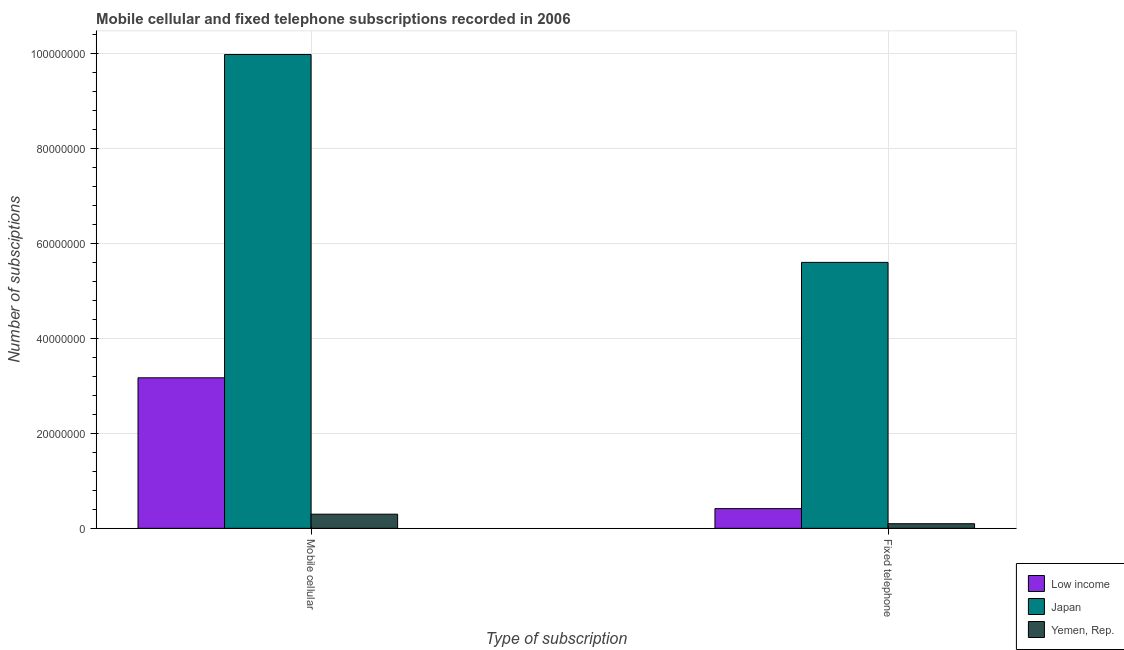What is the label of the 1st group of bars from the left?
Your answer should be very brief. Mobile cellular. What is the number of fixed telephone subscriptions in Japan?
Provide a short and direct response. 5.60e+07. Across all countries, what is the maximum number of mobile cellular subscriptions?
Your response must be concise. 9.98e+07. Across all countries, what is the minimum number of mobile cellular subscriptions?
Provide a succinct answer. 2.98e+06. In which country was the number of mobile cellular subscriptions maximum?
Offer a very short reply. Japan. In which country was the number of mobile cellular subscriptions minimum?
Give a very brief answer. Yemen, Rep. What is the total number of mobile cellular subscriptions in the graph?
Provide a short and direct response. 1.35e+08. What is the difference between the number of mobile cellular subscriptions in Low income and that in Yemen, Rep.?
Keep it short and to the point. 2.87e+07. What is the difference between the number of fixed telephone subscriptions in Yemen, Rep. and the number of mobile cellular subscriptions in Low income?
Make the answer very short. -3.07e+07. What is the average number of mobile cellular subscriptions per country?
Offer a terse response. 4.48e+07. What is the difference between the number of fixed telephone subscriptions and number of mobile cellular subscriptions in Japan?
Your answer should be compact. -4.38e+07. In how many countries, is the number of fixed telephone subscriptions greater than 40000000 ?
Provide a succinct answer. 1. What is the ratio of the number of fixed telephone subscriptions in Japan to that in Yemen, Rep.?
Ensure brevity in your answer.  57.86. What does the 2nd bar from the left in Fixed telephone represents?
Give a very brief answer. Japan. What does the 1st bar from the right in Mobile cellular represents?
Provide a succinct answer. Yemen, Rep. How many bars are there?
Make the answer very short. 6. Does the graph contain any zero values?
Offer a very short reply. No. Where does the legend appear in the graph?
Keep it short and to the point. Bottom right. What is the title of the graph?
Your response must be concise. Mobile cellular and fixed telephone subscriptions recorded in 2006. Does "Euro area" appear as one of the legend labels in the graph?
Make the answer very short. No. What is the label or title of the X-axis?
Ensure brevity in your answer.  Type of subscription. What is the label or title of the Y-axis?
Ensure brevity in your answer.  Number of subsciptions. What is the Number of subsciptions of Low income in Mobile cellular?
Provide a succinct answer. 3.17e+07. What is the Number of subsciptions in Japan in Mobile cellular?
Offer a very short reply. 9.98e+07. What is the Number of subsciptions of Yemen, Rep. in Mobile cellular?
Ensure brevity in your answer.  2.98e+06. What is the Number of subsciptions of Low income in Fixed telephone?
Provide a succinct answer. 4.15e+06. What is the Number of subsciptions in Japan in Fixed telephone?
Your answer should be very brief. 5.60e+07. What is the Number of subsciptions of Yemen, Rep. in Fixed telephone?
Ensure brevity in your answer.  9.68e+05. Across all Type of subscription, what is the maximum Number of subsciptions in Low income?
Your answer should be very brief. 3.17e+07. Across all Type of subscription, what is the maximum Number of subsciptions in Japan?
Offer a very short reply. 9.98e+07. Across all Type of subscription, what is the maximum Number of subsciptions in Yemen, Rep.?
Ensure brevity in your answer.  2.98e+06. Across all Type of subscription, what is the minimum Number of subsciptions in Low income?
Provide a short and direct response. 4.15e+06. Across all Type of subscription, what is the minimum Number of subsciptions in Japan?
Provide a short and direct response. 5.60e+07. Across all Type of subscription, what is the minimum Number of subsciptions in Yemen, Rep.?
Offer a very short reply. 9.68e+05. What is the total Number of subsciptions of Low income in the graph?
Provide a short and direct response. 3.59e+07. What is the total Number of subsciptions in Japan in the graph?
Provide a succinct answer. 1.56e+08. What is the total Number of subsciptions in Yemen, Rep. in the graph?
Offer a terse response. 3.95e+06. What is the difference between the Number of subsciptions in Low income in Mobile cellular and that in Fixed telephone?
Provide a short and direct response. 2.76e+07. What is the difference between the Number of subsciptions in Japan in Mobile cellular and that in Fixed telephone?
Provide a short and direct response. 4.38e+07. What is the difference between the Number of subsciptions in Yemen, Rep. in Mobile cellular and that in Fixed telephone?
Your response must be concise. 2.01e+06. What is the difference between the Number of subsciptions of Low income in Mobile cellular and the Number of subsciptions of Japan in Fixed telephone?
Give a very brief answer. -2.43e+07. What is the difference between the Number of subsciptions in Low income in Mobile cellular and the Number of subsciptions in Yemen, Rep. in Fixed telephone?
Make the answer very short. 3.07e+07. What is the difference between the Number of subsciptions of Japan in Mobile cellular and the Number of subsciptions of Yemen, Rep. in Fixed telephone?
Offer a terse response. 9.89e+07. What is the average Number of subsciptions of Low income per Type of subscription?
Give a very brief answer. 1.79e+07. What is the average Number of subsciptions in Japan per Type of subscription?
Offer a very short reply. 7.79e+07. What is the average Number of subsciptions in Yemen, Rep. per Type of subscription?
Ensure brevity in your answer.  1.97e+06. What is the difference between the Number of subsciptions in Low income and Number of subsciptions in Japan in Mobile cellular?
Provide a succinct answer. -6.81e+07. What is the difference between the Number of subsciptions of Low income and Number of subsciptions of Yemen, Rep. in Mobile cellular?
Provide a short and direct response. 2.87e+07. What is the difference between the Number of subsciptions of Japan and Number of subsciptions of Yemen, Rep. in Mobile cellular?
Keep it short and to the point. 9.68e+07. What is the difference between the Number of subsciptions of Low income and Number of subsciptions of Japan in Fixed telephone?
Your answer should be very brief. -5.19e+07. What is the difference between the Number of subsciptions of Low income and Number of subsciptions of Yemen, Rep. in Fixed telephone?
Your answer should be very brief. 3.18e+06. What is the difference between the Number of subsciptions in Japan and Number of subsciptions in Yemen, Rep. in Fixed telephone?
Your answer should be very brief. 5.51e+07. What is the ratio of the Number of subsciptions in Low income in Mobile cellular to that in Fixed telephone?
Offer a very short reply. 7.65. What is the ratio of the Number of subsciptions in Japan in Mobile cellular to that in Fixed telephone?
Offer a terse response. 1.78. What is the ratio of the Number of subsciptions of Yemen, Rep. in Mobile cellular to that in Fixed telephone?
Make the answer very short. 3.08. What is the difference between the highest and the second highest Number of subsciptions in Low income?
Give a very brief answer. 2.76e+07. What is the difference between the highest and the second highest Number of subsciptions of Japan?
Keep it short and to the point. 4.38e+07. What is the difference between the highest and the second highest Number of subsciptions of Yemen, Rep.?
Provide a short and direct response. 2.01e+06. What is the difference between the highest and the lowest Number of subsciptions of Low income?
Give a very brief answer. 2.76e+07. What is the difference between the highest and the lowest Number of subsciptions in Japan?
Your answer should be very brief. 4.38e+07. What is the difference between the highest and the lowest Number of subsciptions in Yemen, Rep.?
Provide a succinct answer. 2.01e+06. 